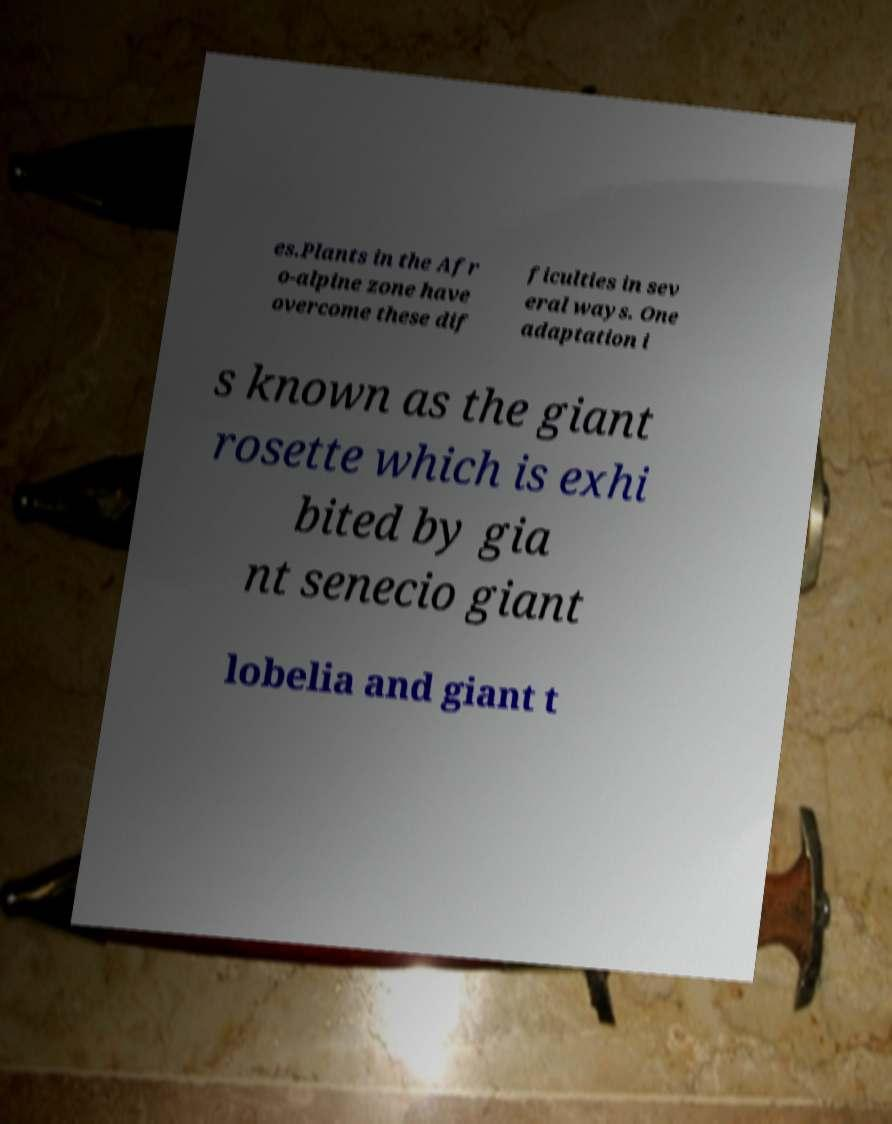Please read and relay the text visible in this image. What does it say? es.Plants in the Afr o-alpine zone have overcome these dif ficulties in sev eral ways. One adaptation i s known as the giant rosette which is exhi bited by gia nt senecio giant lobelia and giant t 